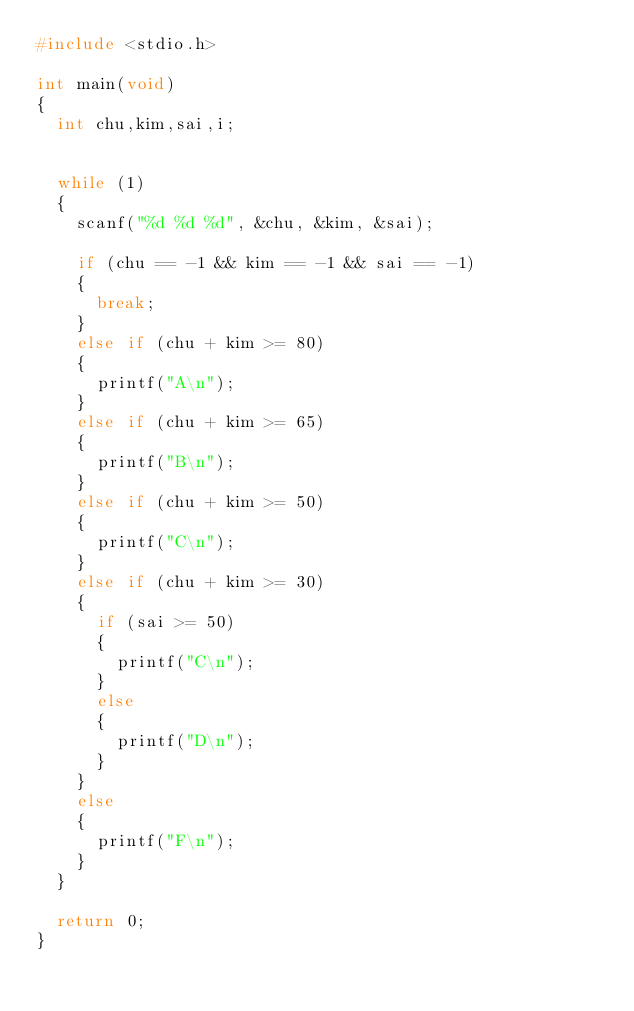<code> <loc_0><loc_0><loc_500><loc_500><_C_>#include <stdio.h>

int main(void)
{
	int chu,kim,sai,i;

	
	while (1)
	{
		scanf("%d %d %d", &chu, &kim, &sai);

		if (chu == -1 && kim == -1 && sai == -1)
		{
			break;
		}
		else if (chu + kim >= 80)
		{
			printf("A\n");
		}
		else if (chu + kim >= 65)
		{
			printf("B\n");
		}
		else if (chu + kim >= 50)
		{
			printf("C\n");
		}
		else if (chu + kim >= 30)
		{
			if (sai >= 50)
			{
				printf("C\n");
			}
			else
			{
				printf("D\n");
			}
		}
		else 
		{
			printf("F\n");
		}
	}

	return 0;
}
</code> 